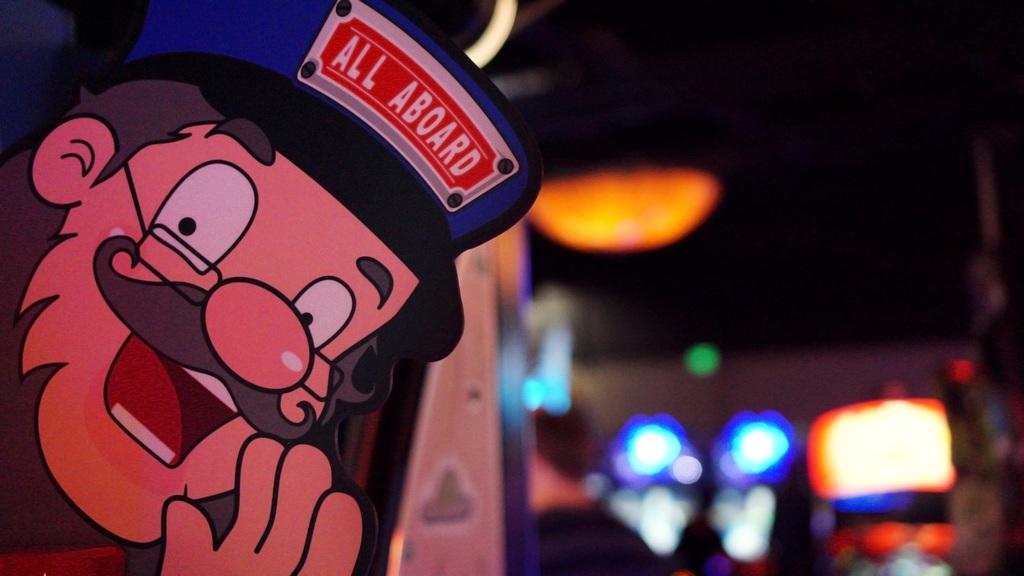What type of visual content is on the left side of the image? There is a cartoon on the left side of the image. What can be seen in the background of the image? There are lights visible in the background of the image. How many tigers are swimming with the ducks in the image? There are no tigers or ducks present in the image; it features a cartoon and lights in the background. 